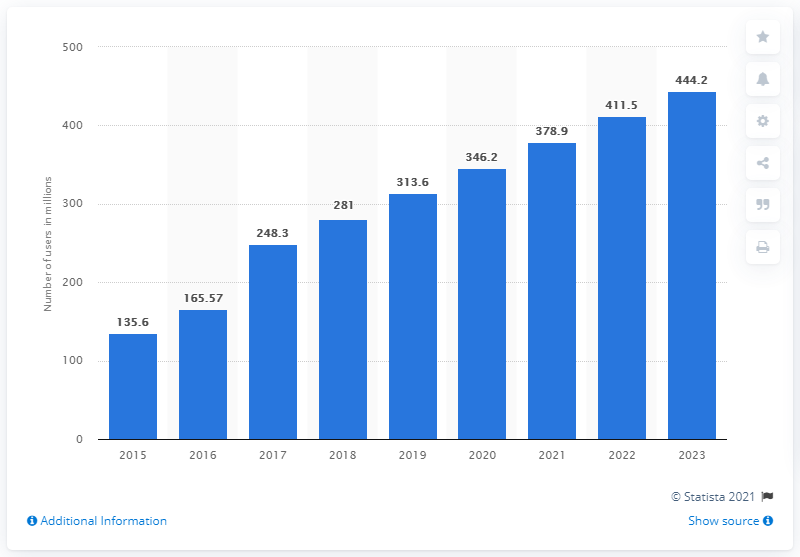Point out several critical features in this image. In 2018, India's Facebook user base was 281 million. According to projections, the number of Facebook users in India is expected to reach 444.2 million by the year 2023. According to projections, India's Facebook user base was expected to reach 444.2 million by 2023. 